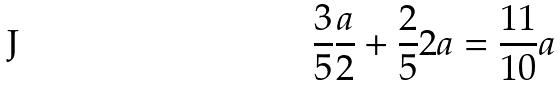<formula> <loc_0><loc_0><loc_500><loc_500>\frac { 3 } { 5 } \frac { a } { 2 } + \frac { 2 } { 5 } 2 a = \frac { 1 1 } { 1 0 } a</formula> 